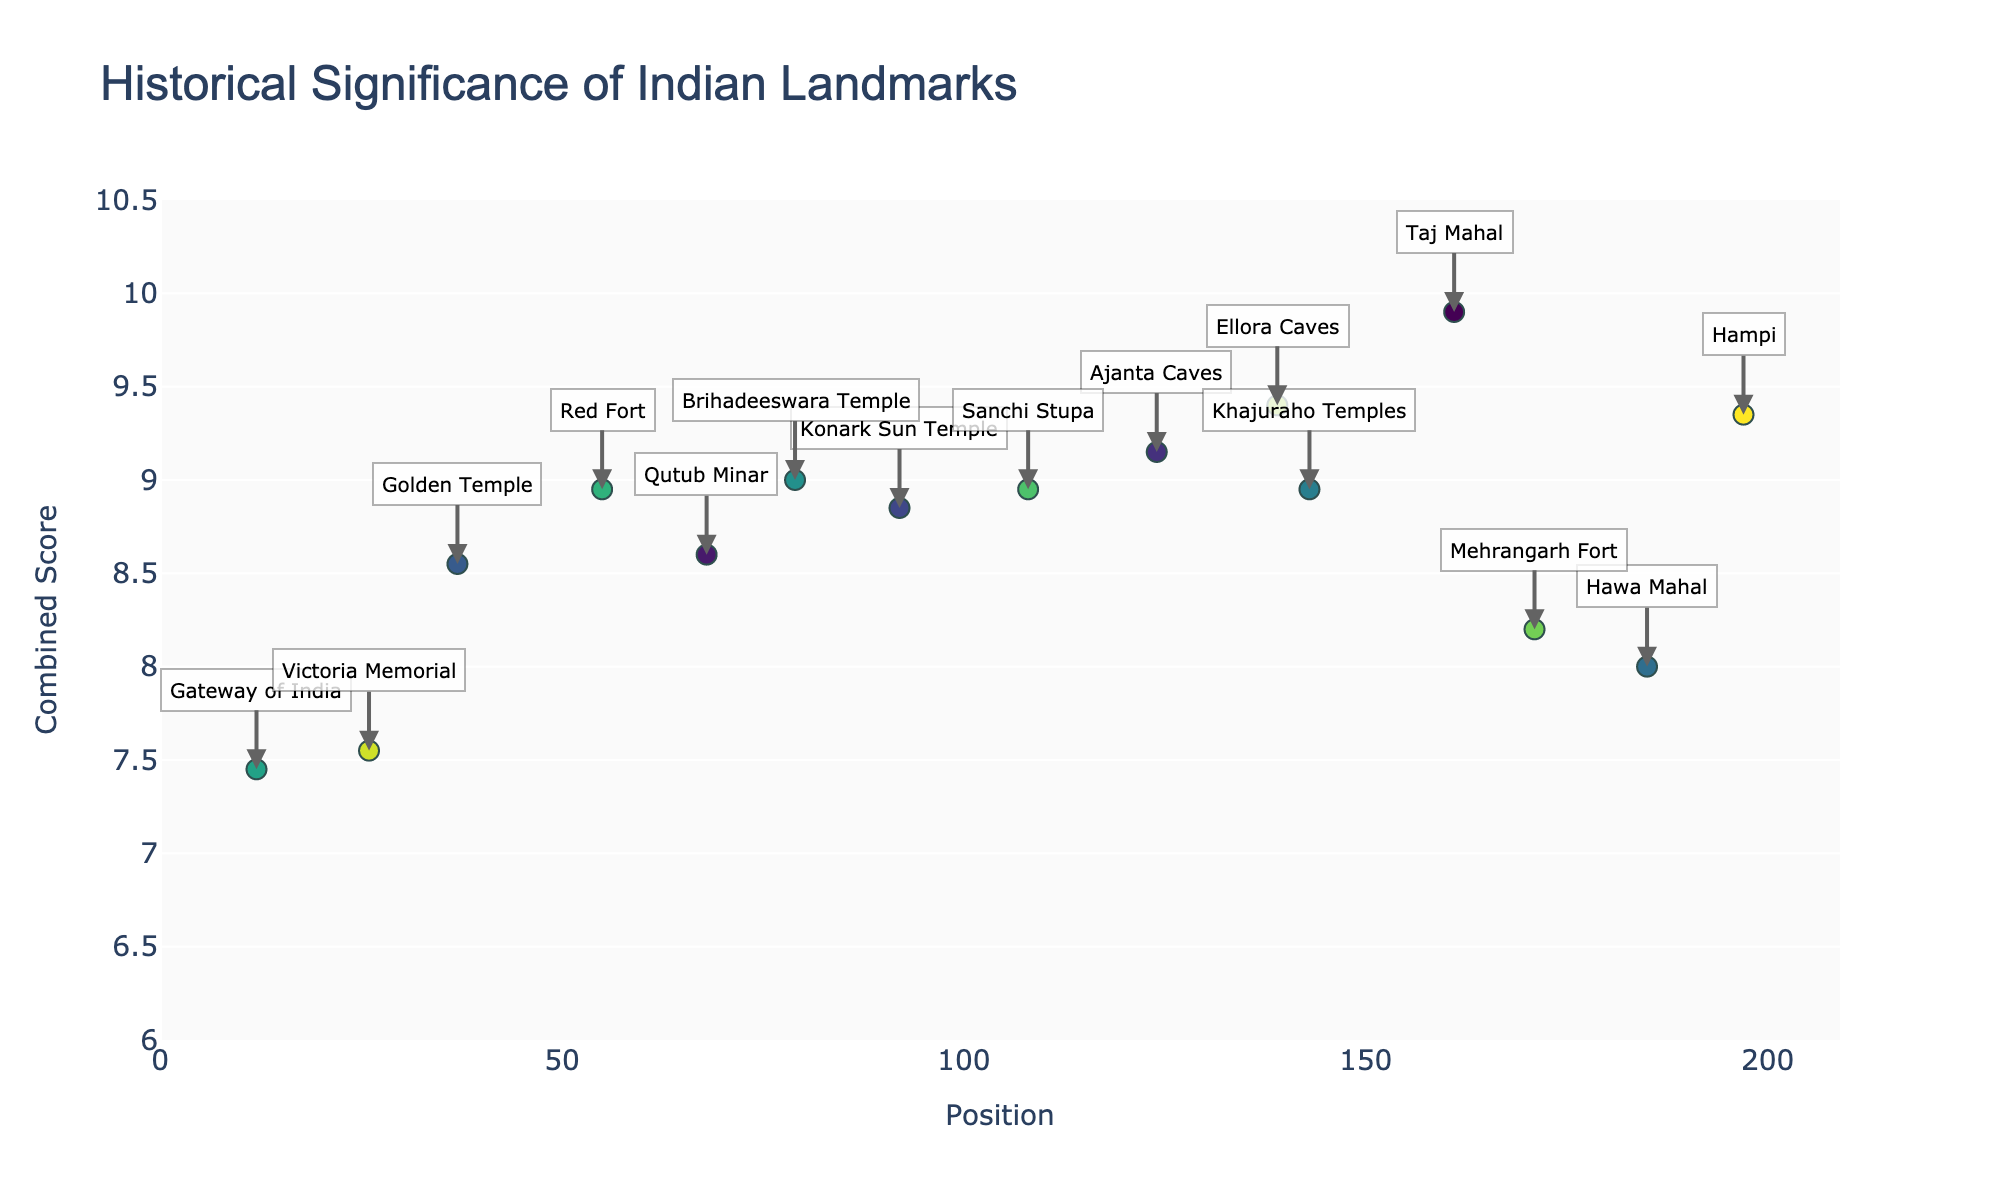What is the title of the figure? The title is usually displayed prominently at the top of the figure. In this case, the title is mentioned in the layout configuration.
Answer: Historical Significance of Indian Landmarks What is the combined score of the landmark at position 37? The specific landmark at position 37 is the Golden Temple, and its combined score can be read directly from the y-axis.
Answer: 8.55 Which landmark has the highest combined score? By scanning the plot for the highest point on the y-axis, the landmark with the highest combined score can be identified.
Answer: Taj Mahal What is the average combined score of the landmarks on Chromosome 4? Only the Konark Sun Temple is on Chromosome 4, with a combined score of 8.85. Hence, the average is the same.
Answer: 8.85 Which two landmarks have the closest combined scores? By examining the plot, the landmarks with the closest y-values are compared.
Answer: Khajuraho Temples and Qutub Minar How many landmarks have a combined score greater than 9? By counting the data points above the 9 mark on the y-axis, we can determine the number.
Answer: 7 Which landmark on Chromosome 9 has the lowest combined score? Since there is only one landmark (Gateway of India) on Chromosome 9, it is the one with the lowest combined score.
Answer: Gateway of India What is the difference in combined score between the landmark at chromosome 5 position 37 and chromosome 8 position 79? The Golden Temple (chromosome 5, position 37) has a combined score of 8.55, and the Brihadeeswara Temple (chromosome 8, position 79) has a combined score of 9.0. The difference is calculated as 9.0 - 8.55.
Answer: 0.45 Which chromosome has the highest average combined score for its landmarks? Calculate the combined scores for landmarks in each chromosome and then find the average. Compare these averages to find the highest one.
Answer: Chromosome 11 